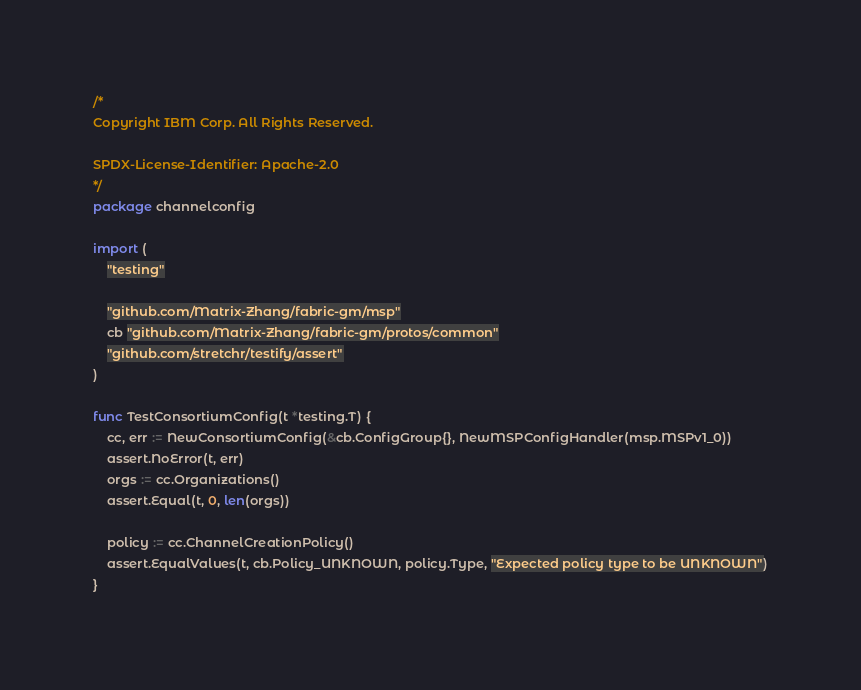<code> <loc_0><loc_0><loc_500><loc_500><_Go_>/*
Copyright IBM Corp. All Rights Reserved.

SPDX-License-Identifier: Apache-2.0
*/
package channelconfig

import (
	"testing"

	"github.com/Matrix-Zhang/fabric-gm/msp"
	cb "github.com/Matrix-Zhang/fabric-gm/protos/common"
	"github.com/stretchr/testify/assert"
)

func TestConsortiumConfig(t *testing.T) {
	cc, err := NewConsortiumConfig(&cb.ConfigGroup{}, NewMSPConfigHandler(msp.MSPv1_0))
	assert.NoError(t, err)
	orgs := cc.Organizations()
	assert.Equal(t, 0, len(orgs))

	policy := cc.ChannelCreationPolicy()
	assert.EqualValues(t, cb.Policy_UNKNOWN, policy.Type, "Expected policy type to be UNKNOWN")
}
</code> 